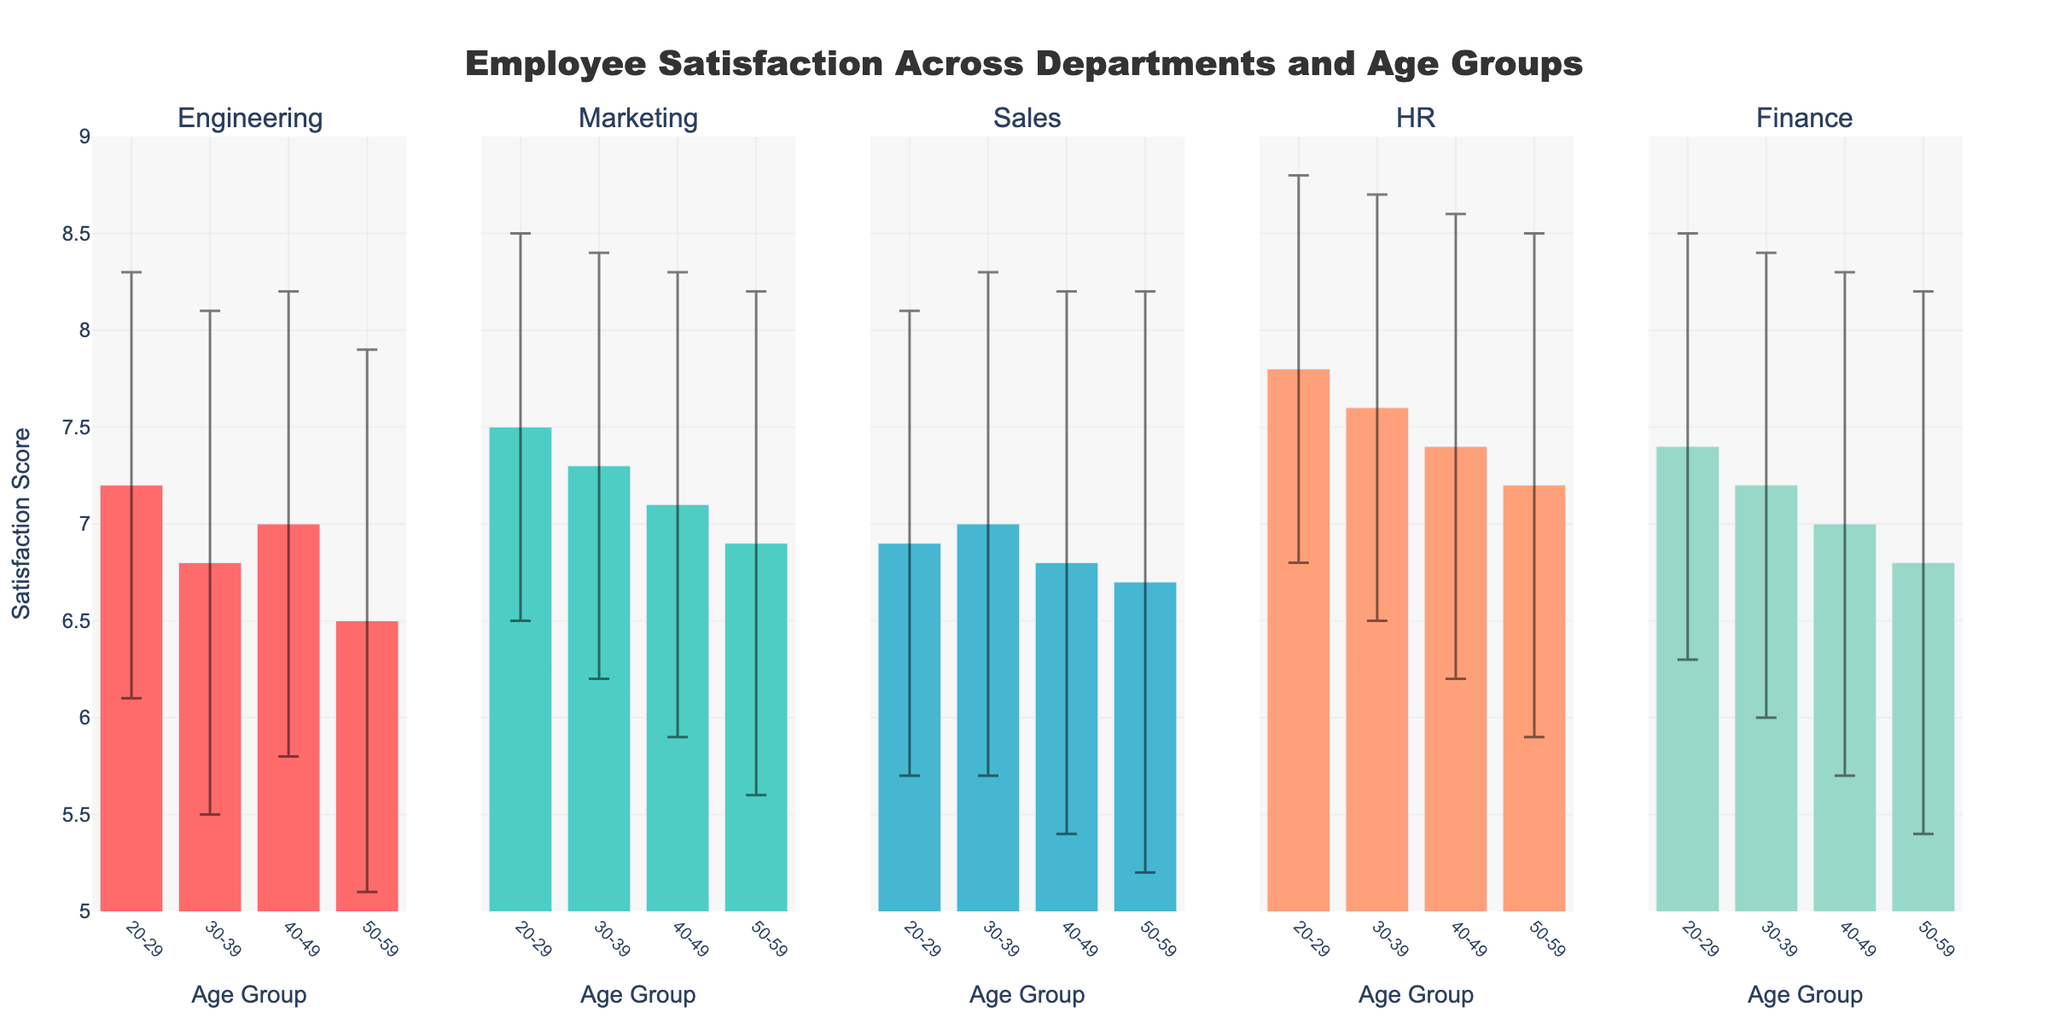what is the title of the figure? The title is displayed at the top of the figure and reads "Employee Satisfaction Across Departments and Age Groups".
Answer: Employee Satisfaction Across Departments and Age Groups What are the age groups represented in the figure? The age groups are displayed on the x-axes of the subplots. Each subplot shows the age groups: 20-29, 30-39, 40-49, and 50-59.
Answer: 20-29, 30-39, 40-49, 50-59 Which department has the highest mean satisfaction score for the age group 20-29? By examining the subplot for each department and looking at the mean satisfaction scores for the age group 20-29, HR shows the highest satisfaction score of 7.8.
Answer: HR What is the difference in mean satisfaction scores between the age groups 20-29 and 50-59 in Finance? The mean satisfaction in Finance for 20-29 is 7.4 and for 50-59 is 6.8. The difference is calculated as 7.4 - 6.8 = 0.6.
Answer: 0.6 Which two age groups have the closest mean satisfaction scores in Sales? The mean scores in Sales are: 6.9 (20-29), 7.0 (30-39), 6.8 (40-49), and 6.7 (50-59). The closest scores are 6.8 (40-49) and 6.7 (50-59) with a difference of 0.1.
Answer: 40-49 and 50-59 In which department is the mean satisfaction score consistently decreasing with increasing age groups? By analyzing the trends in each subplot, the Engineering department shows a consistently decreasing mean satisfaction score as the age groups increase (7.2, 6.8, 7.0, 6.5).
Answer: Engineering For which age group is the standard deviation of satisfaction scores the highest across all departments? By comparing the standard deviations for each age group in all departments, the age group 50-59 in Sales has the highest standard deviation of 1.5.
Answer: 50-59 in Sales Which age group in Marketing has the lowest mean satisfaction score? The subplot for Marketing shows the mean satisfaction scores for different age groups. Age group 50-59 has the lowest mean satisfaction score of 6.9.
Answer: 50-59 What is the average mean satisfaction score for the HR department across all age groups? The mean satisfaction scores for HR are 7.8 (20-29), 7.6 (30-39), 7.4 (40-49), and 7.2 (50-59). The average is calculated as (7.8 + 7.6 + 7.4 + 7.2) / 4 = 7.5.
Answer: 7.5 Which department shows the least variability in satisfaction scores, as indicated by the error bars, for the age group 30-39? The standard deviation represents the length of the error bars. In the age group 30-39, HR has the least variability with a standard deviation of 1.1.
Answer: HR 